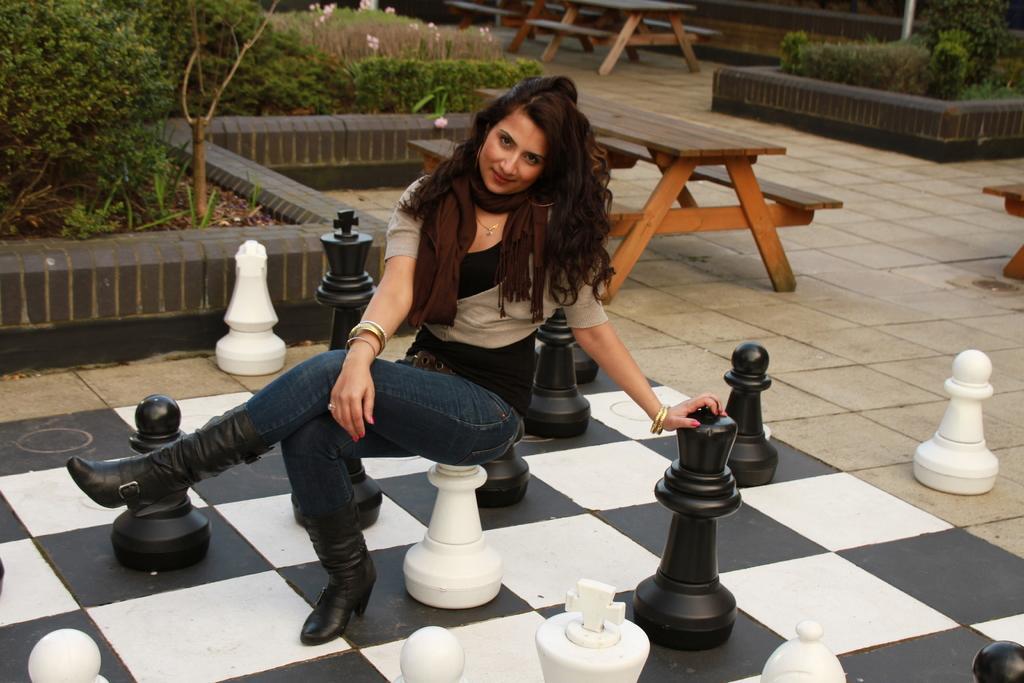Please provide a concise description of this image. In this image there is a person sitting, there are objects on the ground, there are objects truncated towards the bottom of the image, there are benches, there is a bench truncated towards the right of the image, there is a bench truncated towards the top of the image, there are plants truncated towards the top of the image, there are flowers, there is a plant truncated towards the left of the image, there is a pole truncated towards the top of the image. 